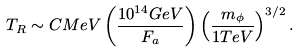Convert formula to latex. <formula><loc_0><loc_0><loc_500><loc_500>T _ { R } \sim C M e V \left ( \frac { 1 0 ^ { 1 4 } G e V } { F _ { a } } \right ) \left ( \frac { m _ { \phi } } { 1 T e V } \right ) ^ { 3 / 2 } .</formula> 